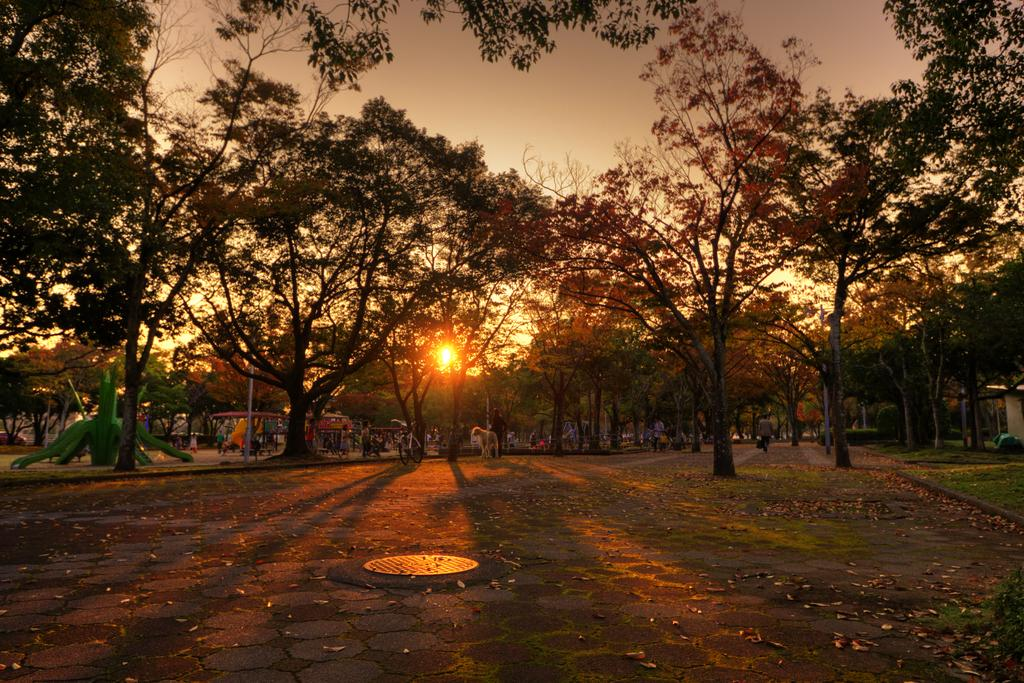What is the primary feature of the image? There are many trees in the image. What can be seen in the background of the image? There are playing things, a cycle, people, and the sky visible in the image. What is the condition of the sky in the image? The sky is visible in the image, and the sun is visible in the sky. What is present on the ground in the image? There are leaves on the ground. What type of story is being told by the jar of pickles in the image? There is no jar of pickles present in the image, so no story can be told by it. 